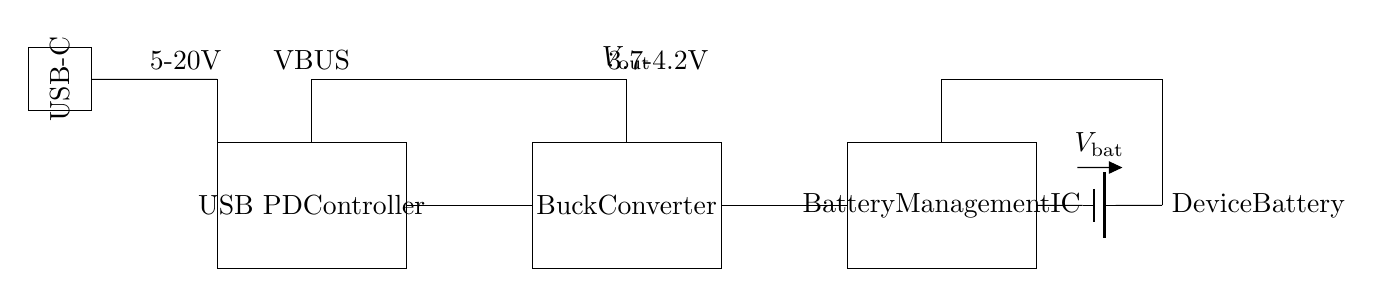What type of connector is used in this circuit? The circuit diagram includes a labeled USB-C connector, which is prominently displayed as a rectangular box with the label "USB-C."
Answer: USB-C What component regulates voltage output? The Buck Converter is the component responsible for regulating the output voltage in the circuit. It is clearly labeled and connected to the output section.
Answer: Buck Converter What is the voltage range of VBUS? The voltage range for VBUS is labeled in the circuit as 5-20V, indicating the potential voltage levels that can be applied through the USB-C connection.
Answer: 5-20V Which component manages the battery? The Battery Management IC is specifically designated in the circuit for managing the battery. It is visually connected to the battery and aids in its operation.
Answer: Battery Management IC How is the output voltage defined? The output voltage, labeled as Vout, is specified as 3.7-4.2V in the diagram, indicating the acceptable range for the battery’s voltage when charging.
Answer: 3.7-4.2V What is the role of the USB PD Controller? The USB PD Controller is the primary control unit in the circuit, responsible for negotiating power delivery and ensuring compatibility with connected devices. It is identified at the start of the circuit.
Answer: Control unit What is the final output delivered to the device battery? The final output delivered from the circuit to the device battery is denoted as Vout, which is a controlled output voltage managed by the prior components in the circuit.
Answer: Vout 